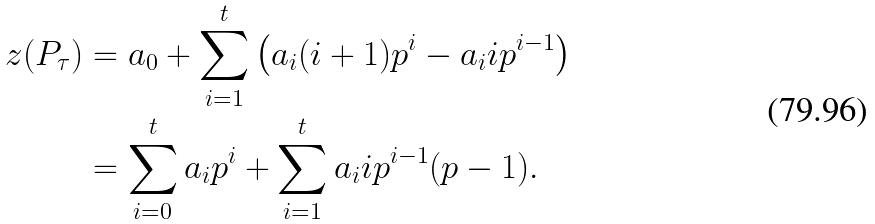<formula> <loc_0><loc_0><loc_500><loc_500>z ( P _ { \tau } ) & = a _ { 0 } + \sum _ { i = 1 } ^ { t } \left ( a _ { i } ( i + 1 ) p ^ { i } - a _ { i } i p ^ { i - 1 } \right ) \\ & = \sum _ { i = 0 } ^ { t } a _ { i } p ^ { i } + \sum _ { i = 1 } ^ { t } a _ { i } i p ^ { i - 1 } ( p - 1 ) .</formula> 